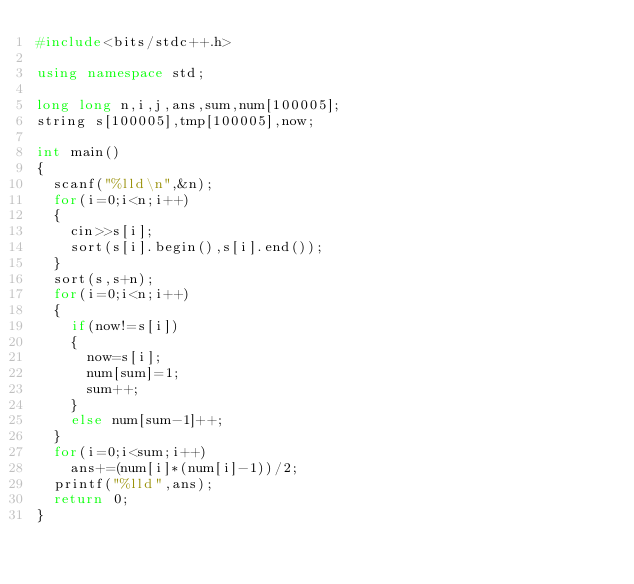Convert code to text. <code><loc_0><loc_0><loc_500><loc_500><_C++_>#include<bits/stdc++.h>

using namespace std;

long long n,i,j,ans,sum,num[100005];
string s[100005],tmp[100005],now;

int main()
{
	scanf("%lld\n",&n);
	for(i=0;i<n;i++)
	{
		cin>>s[i];
		sort(s[i].begin(),s[i].end());
	}
	sort(s,s+n);
	for(i=0;i<n;i++)
	{
		if(now!=s[i])
		{
			now=s[i];
			num[sum]=1;
			sum++;
		}
		else num[sum-1]++;
	}
	for(i=0;i<sum;i++)
		ans+=(num[i]*(num[i]-1))/2;
	printf("%lld",ans);
	return 0;
}</code> 